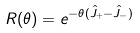<formula> <loc_0><loc_0><loc_500><loc_500>R ( \theta ) = e ^ { - \theta ( \hat { J } _ { + } - \hat { J } _ { - } ) }</formula> 